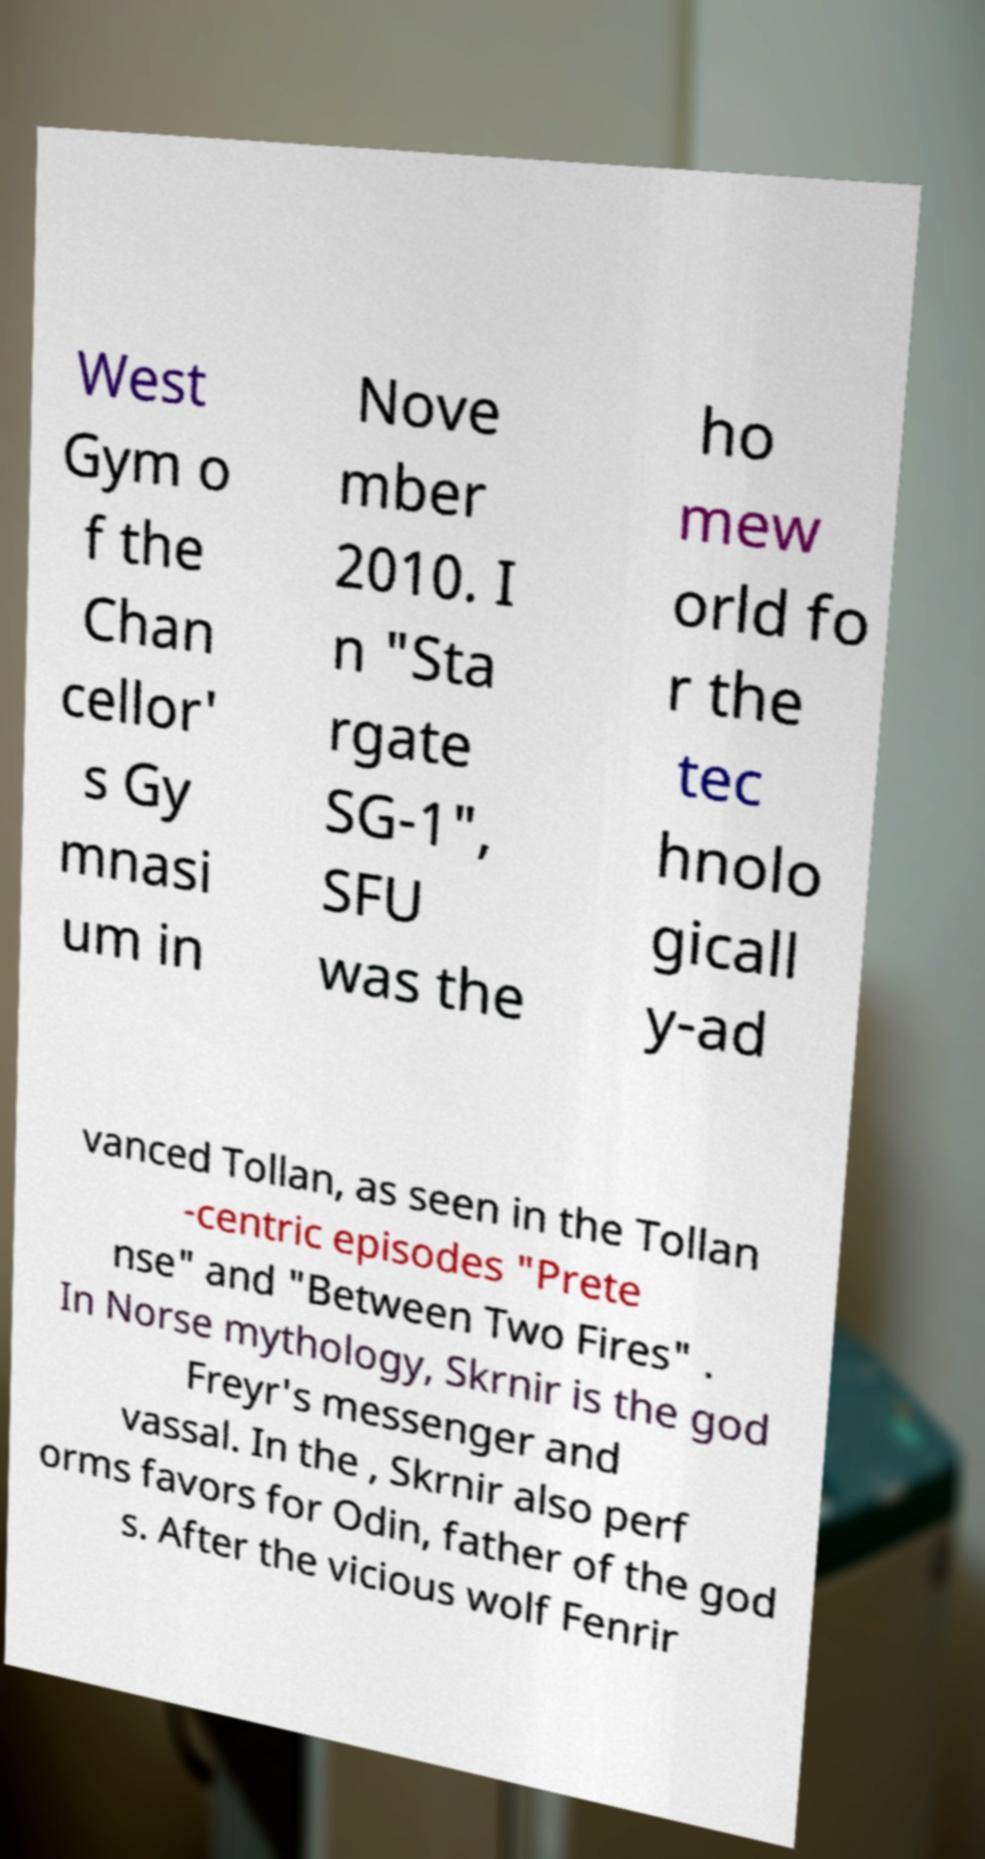Could you assist in decoding the text presented in this image and type it out clearly? West Gym o f the Chan cellor' s Gy mnasi um in Nove mber 2010. I n "Sta rgate SG-1", SFU was the ho mew orld fo r the tec hnolo gicall y-ad vanced Tollan, as seen in the Tollan -centric episodes "Prete nse" and "Between Two Fires" . In Norse mythology, Skrnir is the god Freyr's messenger and vassal. In the , Skrnir also perf orms favors for Odin, father of the god s. After the vicious wolf Fenrir 